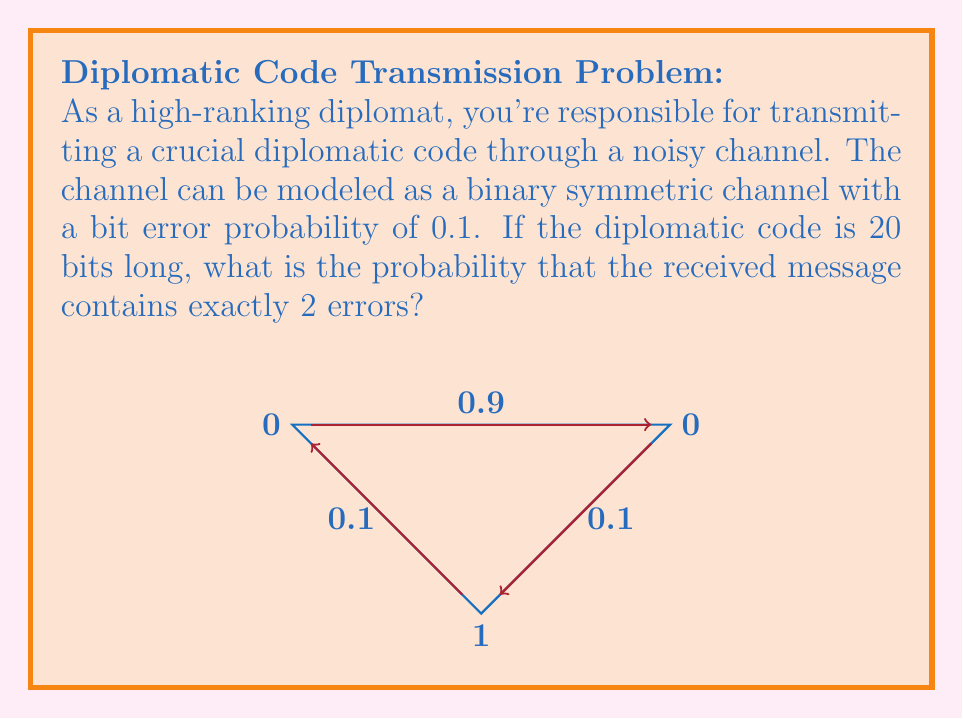What is the answer to this math problem? To solve this problem, we can use the binomial probability formula:

1) The probability of a single bit being transmitted correctly is $1 - 0.1 = 0.9$

2) The probability of a single bit being transmitted incorrectly is $0.1$

3) We want exactly 2 errors in 20 bits, so we use the binomial probability formula:

   $P(X = k) = \binom{n}{k} p^k (1-p)^{n-k}$

   Where:
   $n = 20$ (total number of bits)
   $k = 2$ (number of errors we want)
   $p = 0.1$ (probability of an error)

4) Substituting these values:

   $P(X = 2) = \binom{20}{2} (0.1)^2 (0.9)^{18}$

5) Calculate the binomial coefficient:
   
   $\binom{20}{2} = \frac{20!}{2!(20-2)!} = \frac{20 * 19}{2} = 190$

6) Now we can compute:

   $P(X = 2) = 190 * (0.1)^2 * (0.9)^{18}$

7) Using a calculator:

   $P(X = 2) \approx 190 * 0.01 * 0.150094635296999 \approx 0.285179807$

Therefore, the probability of receiving exactly 2 errors in the 20-bit diplomatic code is approximately 0.285 or 28.5%.
Answer: $0.285$ 